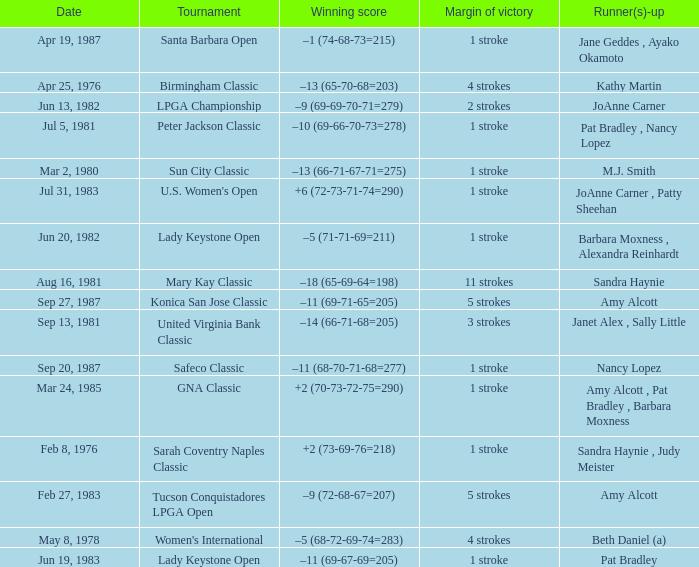Would you mind parsing the complete table? {'header': ['Date', 'Tournament', 'Winning score', 'Margin of victory', 'Runner(s)-up'], 'rows': [['Apr 19, 1987', 'Santa Barbara Open', '–1 (74-68-73=215)', '1 stroke', 'Jane Geddes , Ayako Okamoto'], ['Apr 25, 1976', 'Birmingham Classic', '–13 (65-70-68=203)', '4 strokes', 'Kathy Martin'], ['Jun 13, 1982', 'LPGA Championship', '–9 (69-69-70-71=279)', '2 strokes', 'JoAnne Carner'], ['Jul 5, 1981', 'Peter Jackson Classic', '–10 (69-66-70-73=278)', '1 stroke', 'Pat Bradley , Nancy Lopez'], ['Mar 2, 1980', 'Sun City Classic', '–13 (66-71-67-71=275)', '1 stroke', 'M.J. Smith'], ['Jul 31, 1983', "U.S. Women's Open", '+6 (72-73-71-74=290)', '1 stroke', 'JoAnne Carner , Patty Sheehan'], ['Jun 20, 1982', 'Lady Keystone Open', '–5 (71-71-69=211)', '1 stroke', 'Barbara Moxness , Alexandra Reinhardt'], ['Aug 16, 1981', 'Mary Kay Classic', '–18 (65-69-64=198)', '11 strokes', 'Sandra Haynie'], ['Sep 27, 1987', 'Konica San Jose Classic', '–11 (69-71-65=205)', '5 strokes', 'Amy Alcott'], ['Sep 13, 1981', 'United Virginia Bank Classic', '–14 (66-71-68=205)', '3 strokes', 'Janet Alex , Sally Little'], ['Sep 20, 1987', 'Safeco Classic', '–11 (68-70-71-68=277)', '1 stroke', 'Nancy Lopez'], ['Mar 24, 1985', 'GNA Classic', '+2 (70-73-72-75=290)', '1 stroke', 'Amy Alcott , Pat Bradley , Barbara Moxness'], ['Feb 8, 1976', 'Sarah Coventry Naples Classic', '+2 (73-69-76=218)', '1 stroke', 'Sandra Haynie , Judy Meister'], ['Feb 27, 1983', 'Tucson Conquistadores LPGA Open', '–9 (72-68-67=207)', '5 strokes', 'Amy Alcott'], ['May 8, 1978', "Women's International", '–5 (68-72-69-74=283)', '4 strokes', 'Beth Daniel (a)'], ['Jun 19, 1983', 'Lady Keystone Open', '–11 (69-67-69=205)', '1 stroke', 'Pat Bradley']]} What is the margin of victory when the runner-up is amy alcott and the winning score is –9 (72-68-67=207)? 5 strokes. 